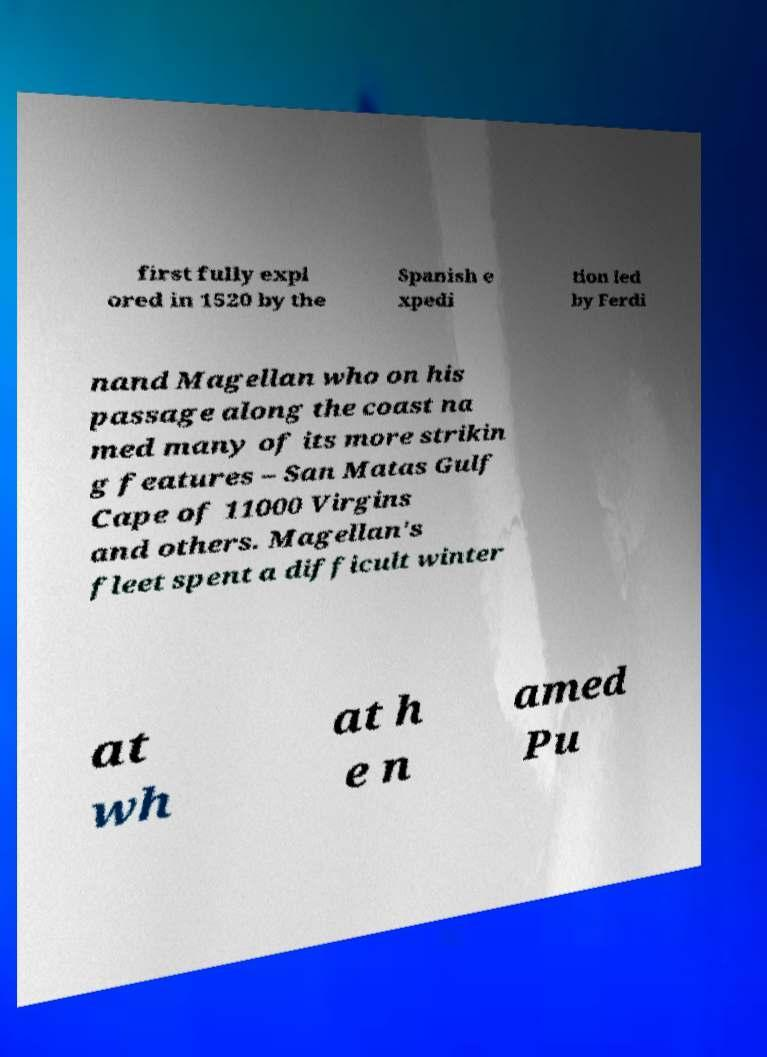Please read and relay the text visible in this image. What does it say? first fully expl ored in 1520 by the Spanish e xpedi tion led by Ferdi nand Magellan who on his passage along the coast na med many of its more strikin g features – San Matas Gulf Cape of 11000 Virgins and others. Magellan's fleet spent a difficult winter at wh at h e n amed Pu 